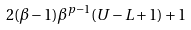<formula> <loc_0><loc_0><loc_500><loc_500>2 ( \beta - 1 ) \beta ^ { p - 1 } ( U - L + 1 ) + 1</formula> 